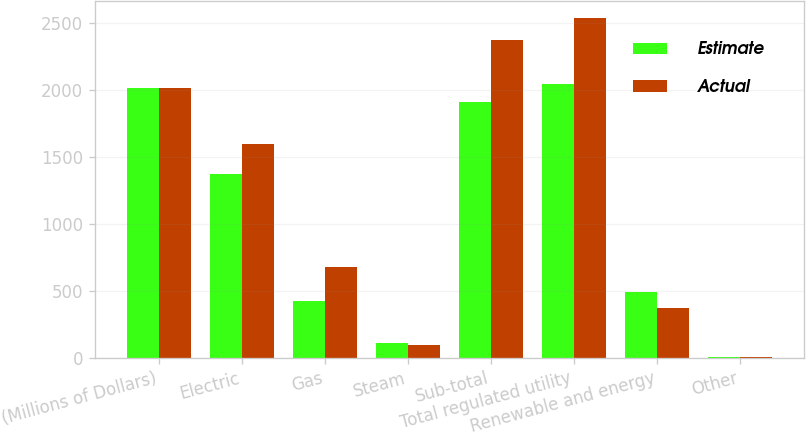Convert chart. <chart><loc_0><loc_0><loc_500><loc_500><stacked_bar_chart><ecel><fcel>(Millions of Dollars)<fcel>Electric<fcel>Gas<fcel>Steam<fcel>Sub-total<fcel>Total regulated utility<fcel>Renewable and energy<fcel>Other<nl><fcel>Estimate<fcel>2012<fcel>1375<fcel>426<fcel>108<fcel>1909<fcel>2046<fcel>489<fcel>3<nl><fcel>Actual<fcel>2015<fcel>1598<fcel>679<fcel>98<fcel>2375<fcel>2537<fcel>370<fcel>5<nl></chart> 